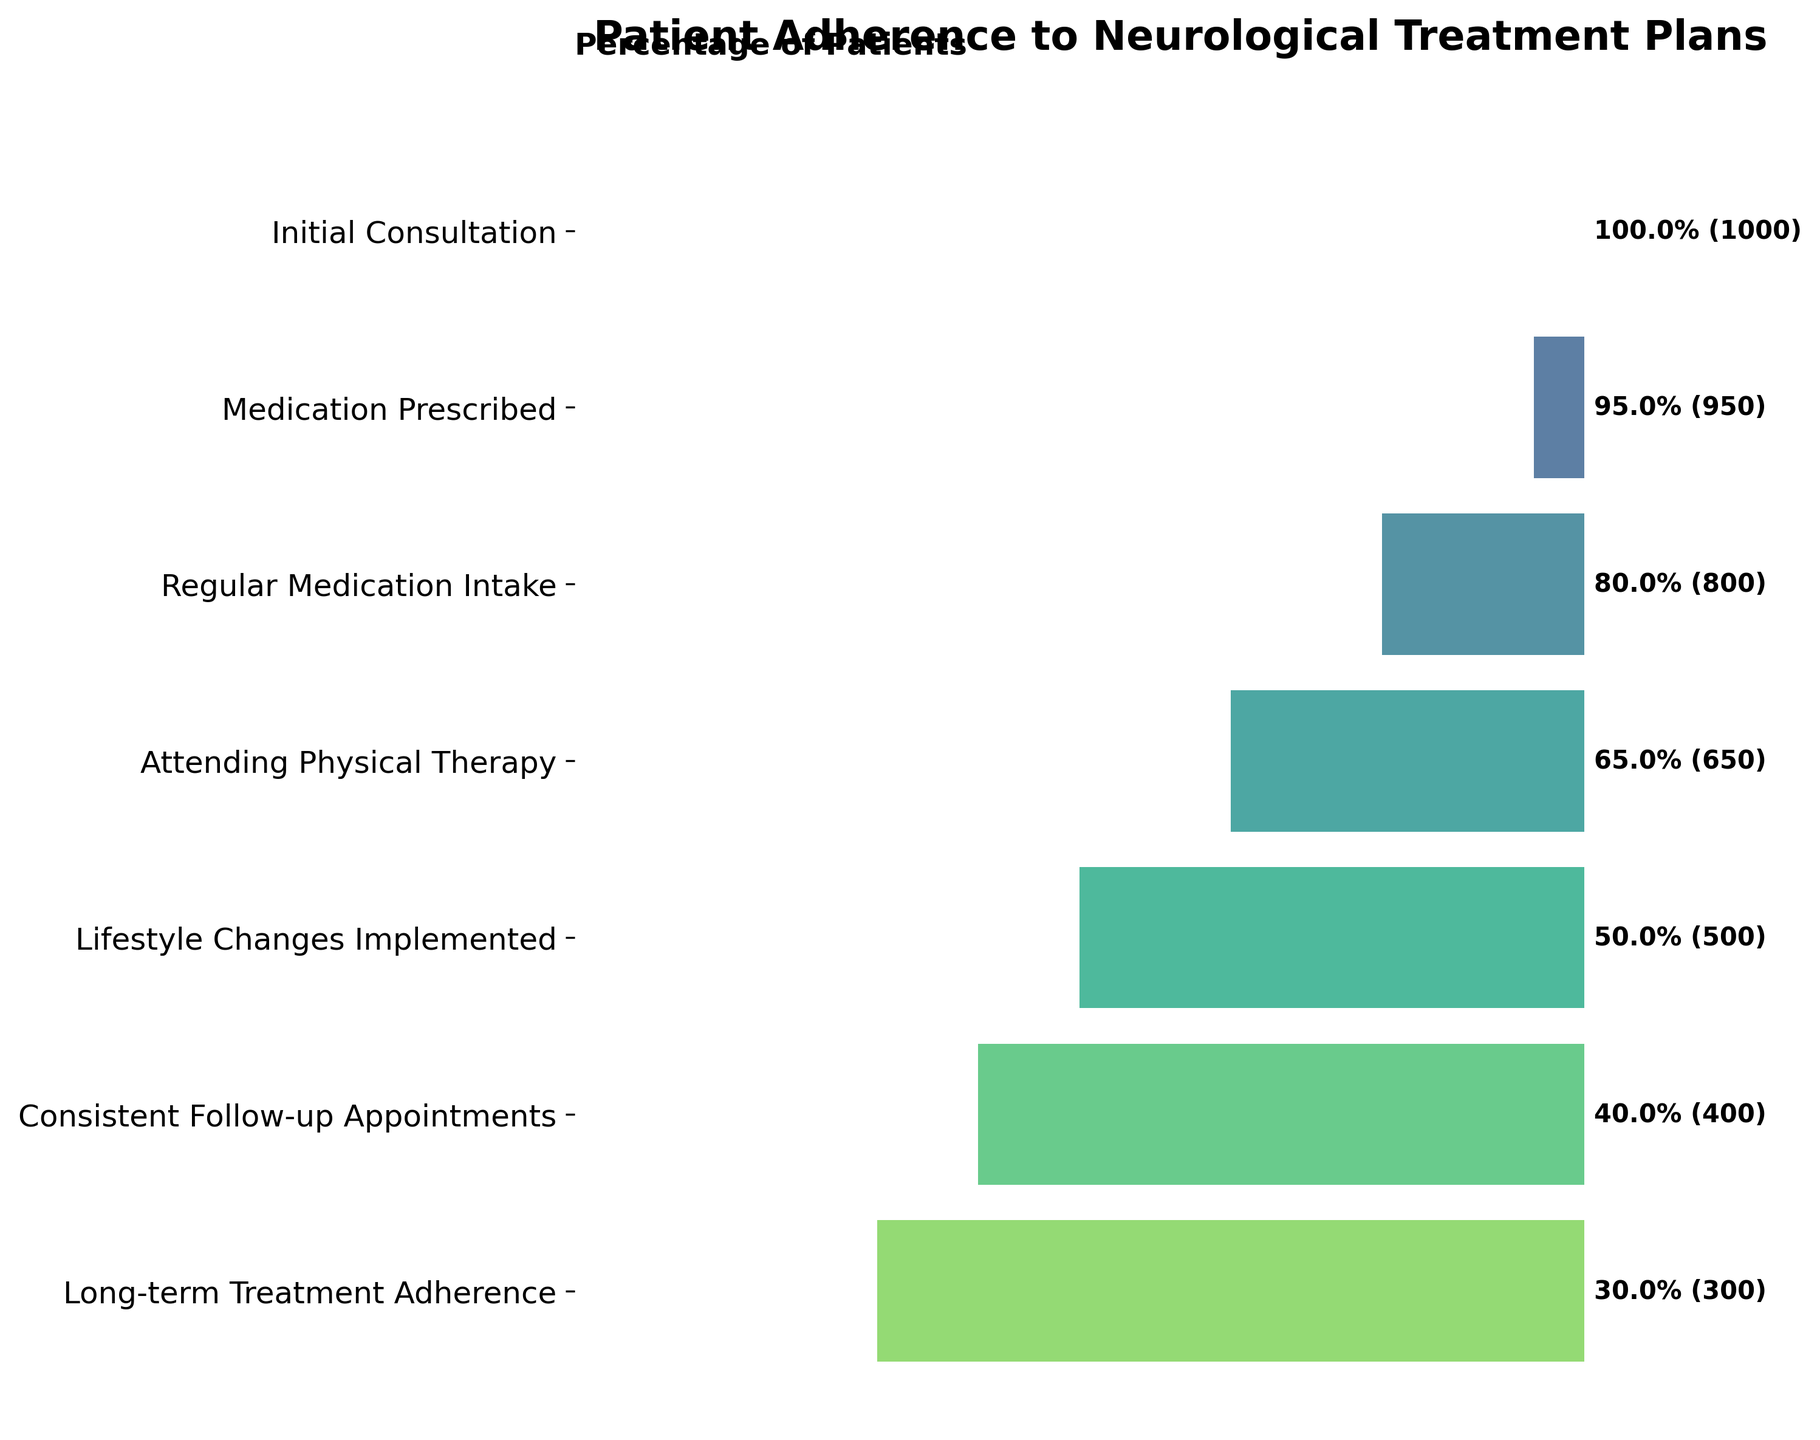What is the title of the funnel chart? The title is displayed at the top of the chart, and it provides an overview of the information being presented. In this case, it states the subject of the data being visualized.
Answer: Patient Adherence to Neurological Treatment Plans What is the percentage of patients who are prescribed medication after the initial consultation? The percentage can be found next to the stage labeled "Medication Prescribed."
Answer: 95% How many patients attend physical therapy out of those who have regular medication intake? Look at the number of patients attending "Physical Therapy" and those with "Regular Medication Intake," then make a comparison based on the number of patients in these stages.
Answer: 650 out of 800 What stage shows a 50% adherence rate? Find the stage where the percentage next to it is 50%.
Answer: Lifestyle Changes Implemented Which stage has the greatest drop in the number of patients compared to its previous stage? Subtract the number of patients in each stage from the previous stage to determine the greatest difference. The largest difference indicates the greatest drop.
Answer: Regular Medication Intake to Attending Physical Therapy (150 patients) What percentage of patients consistently follow up on appointments? Refer to the "Consistent Follow-up Appointments" stage and note the percentage listed next to it.
Answer: 40% How many patients adhere to long-term treatment plans out of those who consistently follow up? Identify the number of patients in the "Long-term Treatment Adherence" stage and compare it to the number of patients in the "Consistent Follow-up Appointments" stage.
Answer: 300 out of 400 Calculate the total number of patients lost from Initial Consultation to Long-term Treatment Adherence. Subtract the number of patients in the "Long-term Treatment Adherence" stage from the number in the "Initial Consultation" stage. The difference represents the total loss.
Answer: 1000 - 300 = 700 By how much does the adherence percentage decrease from patients attending physical therapy to those implementing lifestyle changes? Subtract the percentage of "Lifestyle Changes Implemented" from the percentage of "Attending Physical Therapy" to find the difference.
Answer: 65% - 50% = 15% What are the colors of the bars in the funnel chart? Describe the color scheme used in the bars of the chart, which follow a gradient from the viridis colormap.
Answer: Shades of green to blue from the viridis colormap 